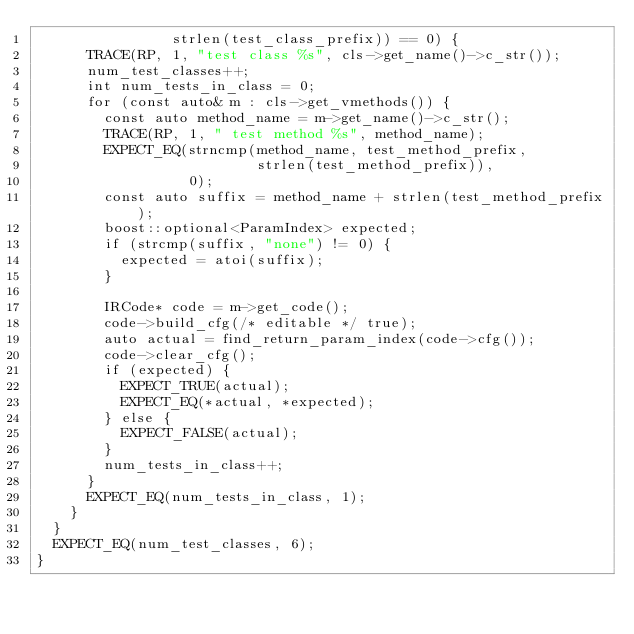<code> <loc_0><loc_0><loc_500><loc_500><_C++_>                strlen(test_class_prefix)) == 0) {
      TRACE(RP, 1, "test class %s", cls->get_name()->c_str());
      num_test_classes++;
      int num_tests_in_class = 0;
      for (const auto& m : cls->get_vmethods()) {
        const auto method_name = m->get_name()->c_str();
        TRACE(RP, 1, " test method %s", method_name);
        EXPECT_EQ(strncmp(method_name, test_method_prefix,
                          strlen(test_method_prefix)),
                  0);
        const auto suffix = method_name + strlen(test_method_prefix);
        boost::optional<ParamIndex> expected;
        if (strcmp(suffix, "none") != 0) {
          expected = atoi(suffix);
        }

        IRCode* code = m->get_code();
        code->build_cfg(/* editable */ true);
        auto actual = find_return_param_index(code->cfg());
        code->clear_cfg();
        if (expected) {
          EXPECT_TRUE(actual);
          EXPECT_EQ(*actual, *expected);
        } else {
          EXPECT_FALSE(actual);
        }
        num_tests_in_class++;
      }
      EXPECT_EQ(num_tests_in_class, 1);
    }
  }
  EXPECT_EQ(num_test_classes, 6);
}
</code> 